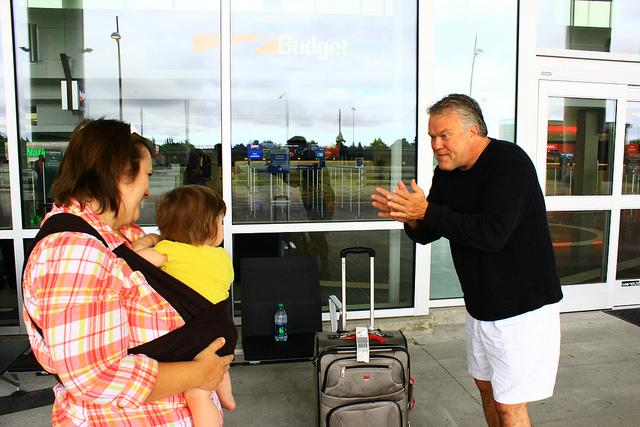What is the woman carrying?

Choices:
A) baby
B) egg
C) basket
D) crown baby 